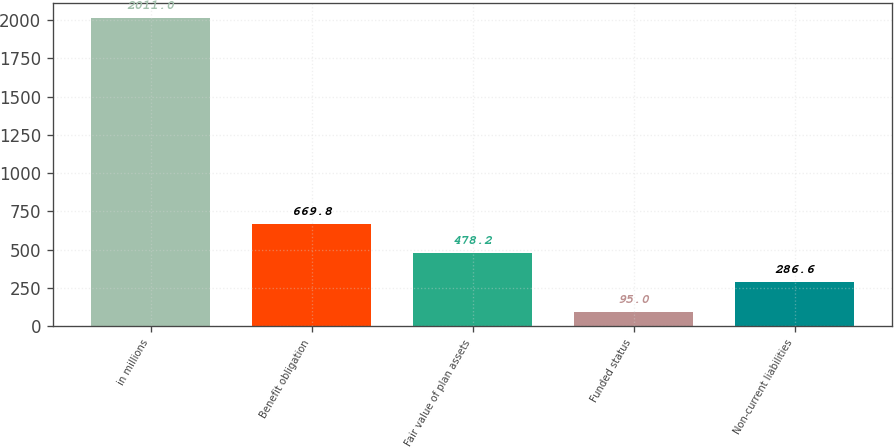<chart> <loc_0><loc_0><loc_500><loc_500><bar_chart><fcel>in millions<fcel>Benefit obligation<fcel>Fair value of plan assets<fcel>Funded status<fcel>Non-current liabilities<nl><fcel>2011<fcel>669.8<fcel>478.2<fcel>95<fcel>286.6<nl></chart> 